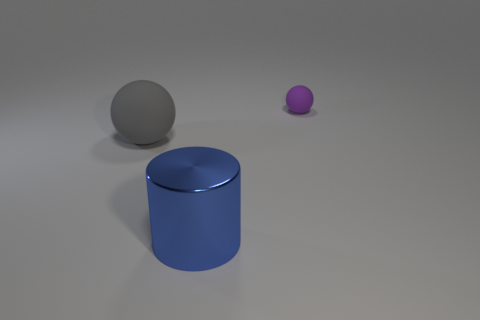There is a large blue metallic object; is its shape the same as the matte thing to the left of the blue metallic object?
Give a very brief answer. No. What number of other objects are the same size as the gray ball?
Offer a very short reply. 1. How many cyan things are either big matte objects or small things?
Provide a short and direct response. 0. What number of objects are to the right of the big gray sphere and in front of the tiny matte object?
Your answer should be compact. 1. What material is the object that is behind the rubber sphere left of the sphere that is on the right side of the blue cylinder made of?
Your response must be concise. Rubber. How many small spheres have the same material as the blue object?
Ensure brevity in your answer.  0. There is a gray thing that is the same size as the blue metal thing; what is its shape?
Your answer should be very brief. Sphere. There is a cylinder; are there any big objects on the left side of it?
Your answer should be very brief. Yes. Are there any other blue things of the same shape as the large matte thing?
Your answer should be very brief. No. Does the matte thing that is to the left of the purple object have the same shape as the blue metallic thing that is on the left side of the small purple rubber sphere?
Provide a short and direct response. No. 